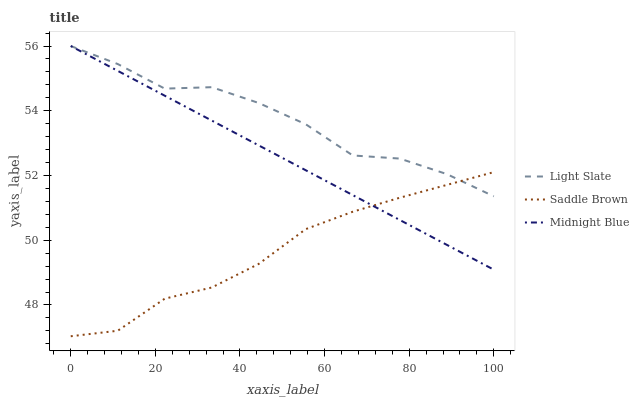Does Saddle Brown have the minimum area under the curve?
Answer yes or no. Yes. Does Light Slate have the maximum area under the curve?
Answer yes or no. Yes. Does Midnight Blue have the minimum area under the curve?
Answer yes or no. No. Does Midnight Blue have the maximum area under the curve?
Answer yes or no. No. Is Midnight Blue the smoothest?
Answer yes or no. Yes. Is Light Slate the roughest?
Answer yes or no. Yes. Is Saddle Brown the smoothest?
Answer yes or no. No. Is Saddle Brown the roughest?
Answer yes or no. No. Does Saddle Brown have the lowest value?
Answer yes or no. Yes. Does Midnight Blue have the lowest value?
Answer yes or no. No. Does Midnight Blue have the highest value?
Answer yes or no. Yes. Does Saddle Brown have the highest value?
Answer yes or no. No. Does Light Slate intersect Midnight Blue?
Answer yes or no. Yes. Is Light Slate less than Midnight Blue?
Answer yes or no. No. Is Light Slate greater than Midnight Blue?
Answer yes or no. No. 